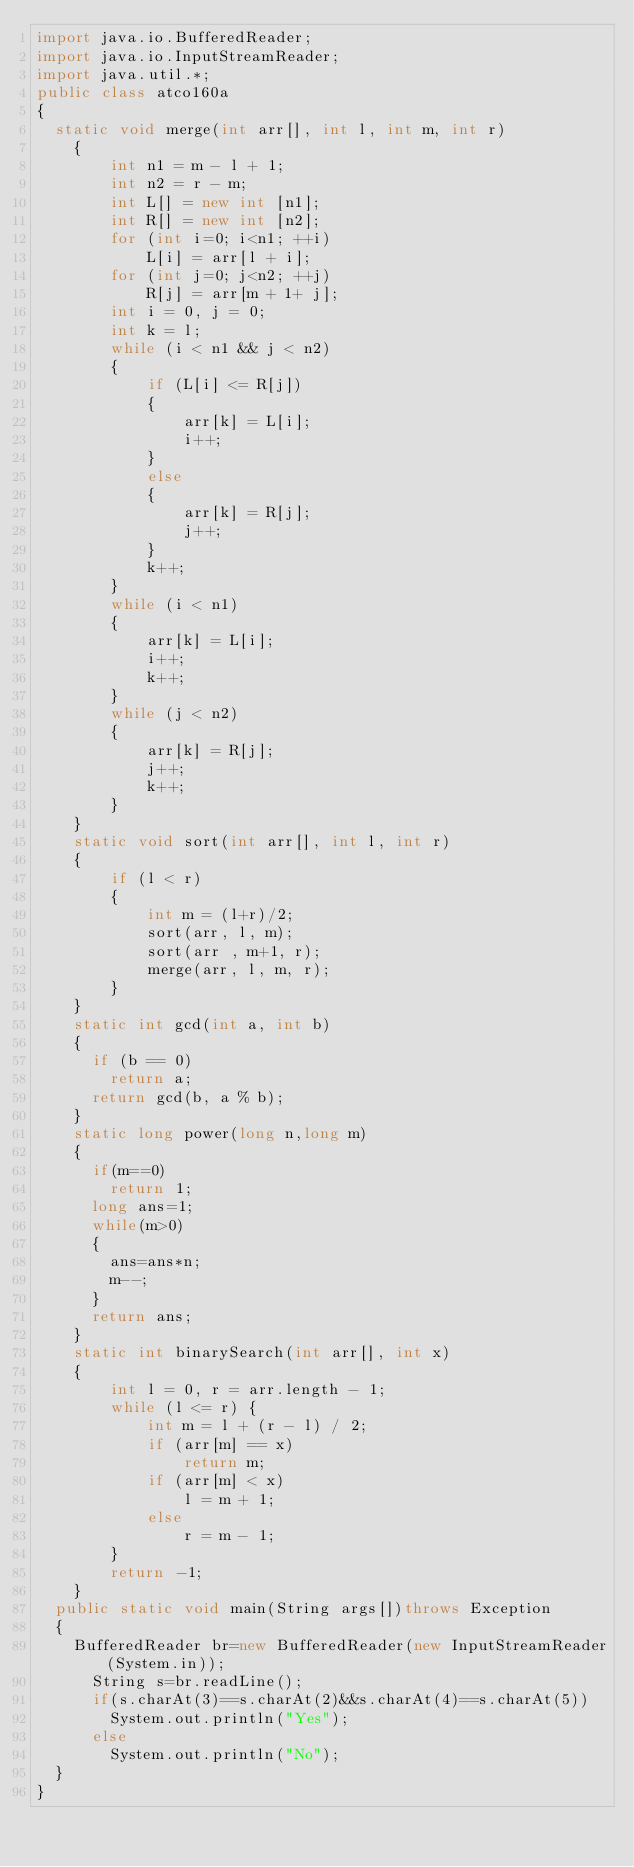<code> <loc_0><loc_0><loc_500><loc_500><_Java_>import java.io.BufferedReader;
import java.io.InputStreamReader;
import java.util.*;
public class atco160a
{
	static void merge(int arr[], int l, int m, int r) 
    { 
        int n1 = m - l + 1; 
        int n2 = r - m; 
        int L[] = new int [n1]; 
        int R[] = new int [n2]; 
        for (int i=0; i<n1; ++i) 
            L[i] = arr[l + i]; 
        for (int j=0; j<n2; ++j) 
            R[j] = arr[m + 1+ j]; 
        int i = 0, j = 0; 
        int k = l; 
        while (i < n1 && j < n2) 
        { 
            if (L[i] <= R[j]) 
            { 
                arr[k] = L[i]; 
                i++; 
            } 
            else
            { 
                arr[k] = R[j]; 
                j++; 
            } 
            k++; 
        } 
        while (i < n1) 
        { 
            arr[k] = L[i]; 
            i++; 
            k++; 
        } 
        while (j < n2) 
        { 
            arr[k] = R[j]; 
            j++; 
            k++; 
        } 
    } 
    static void sort(int arr[], int l, int r) 
    { 
        if (l < r) 
        { 
            int m = (l+r)/2; 
            sort(arr, l, m); 
            sort(arr , m+1, r); 
            merge(arr, l, m, r); 
        } 
    } 
    static int gcd(int a, int b) 
    { 
      if (b == 0) 
        return a; 
      return gcd(b, a % b);  
    } 
    static long power(long n,long m)
    {
    	if(m==0)
    		return 1;
    	long ans=1;
    	while(m>0)
    	{
    		ans=ans*n;
    		m--;
    	}
    	return ans;
    }
    static int binarySearch(int arr[], int x) 
    { 
        int l = 0, r = arr.length - 1; 
        while (l <= r) { 
            int m = l + (r - l) / 2; 
            if (arr[m] == x) 
                return m; 
            if (arr[m] < x) 
                l = m + 1; 
            else
                r = m - 1; 
        } 
        return -1; 
    } 
	public static void main(String args[])throws Exception
	{
		BufferedReader br=new BufferedReader(new InputStreamReader(System.in));
			String s=br.readLine();
			if(s.charAt(3)==s.charAt(2)&&s.charAt(4)==s.charAt(5))
				System.out.println("Yes");
			else
				System.out.println("No");
	}
}
</code> 